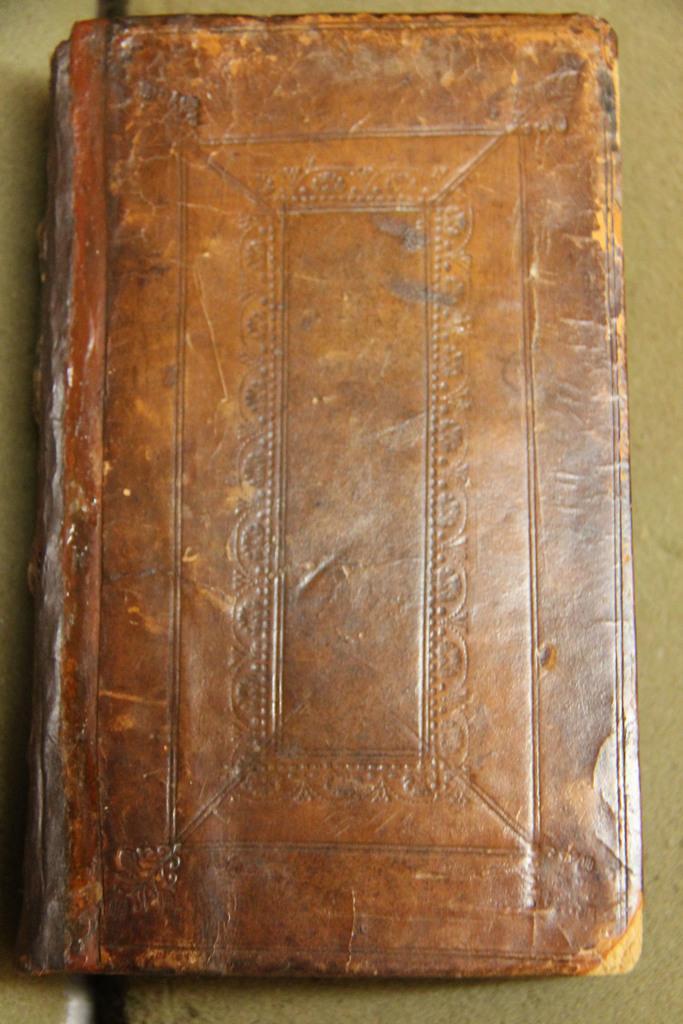Can you describe this image briefly? In the foreground of this picture, there is a book on a green surface. 